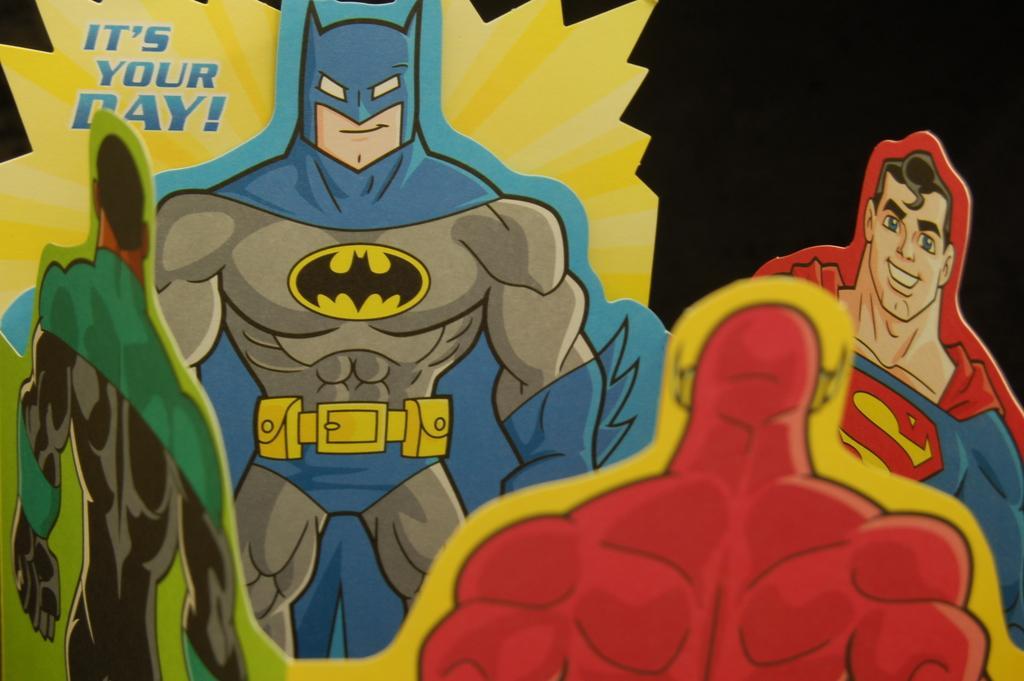Could you give a brief overview of what you see in this image? In this image we can see cartoons. 